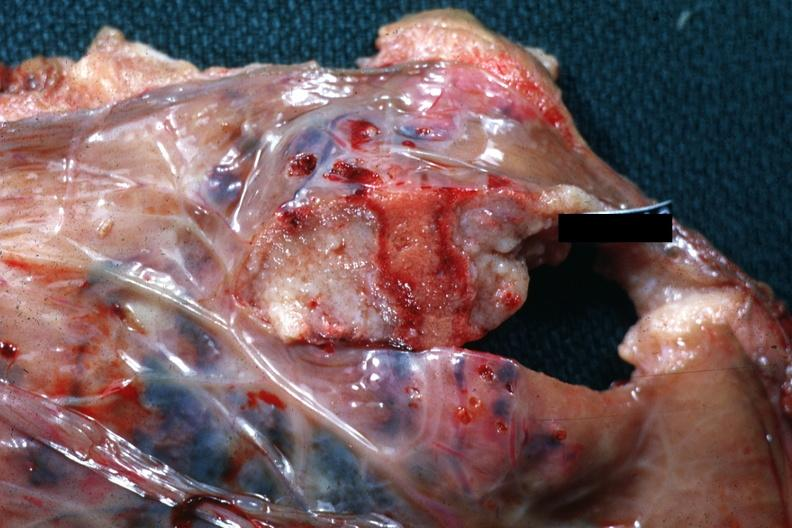what is present?
Answer the question using a single word or phrase. Placenta 